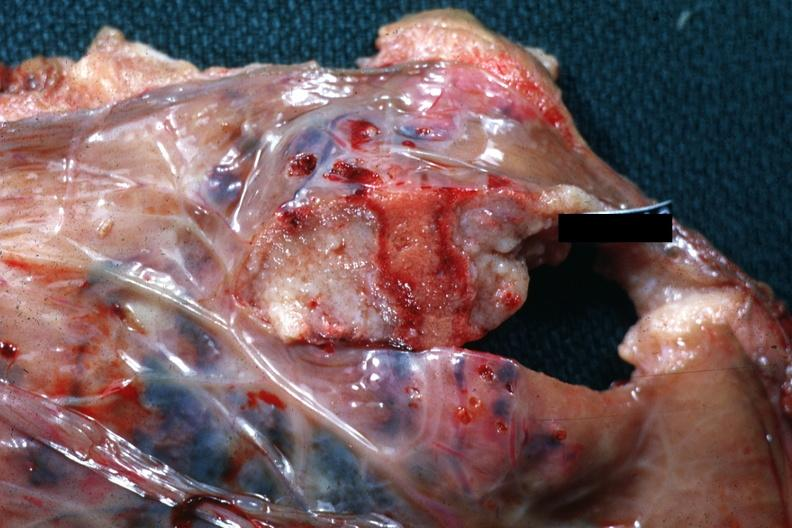what is present?
Answer the question using a single word or phrase. Placenta 